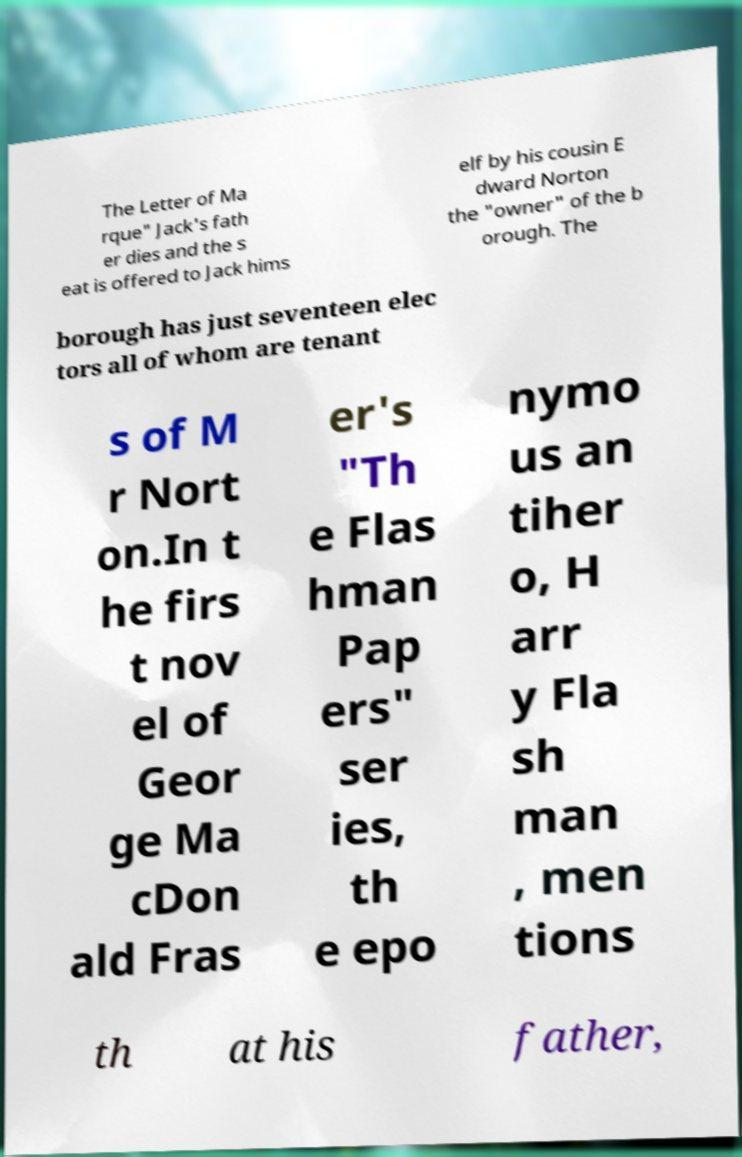For documentation purposes, I need the text within this image transcribed. Could you provide that? The Letter of Ma rque" Jack's fath er dies and the s eat is offered to Jack hims elf by his cousin E dward Norton the "owner" of the b orough. The borough has just seventeen elec tors all of whom are tenant s of M r Nort on.In t he firs t nov el of Geor ge Ma cDon ald Fras er's "Th e Flas hman Pap ers" ser ies, th e epo nymo us an tiher o, H arr y Fla sh man , men tions th at his father, 